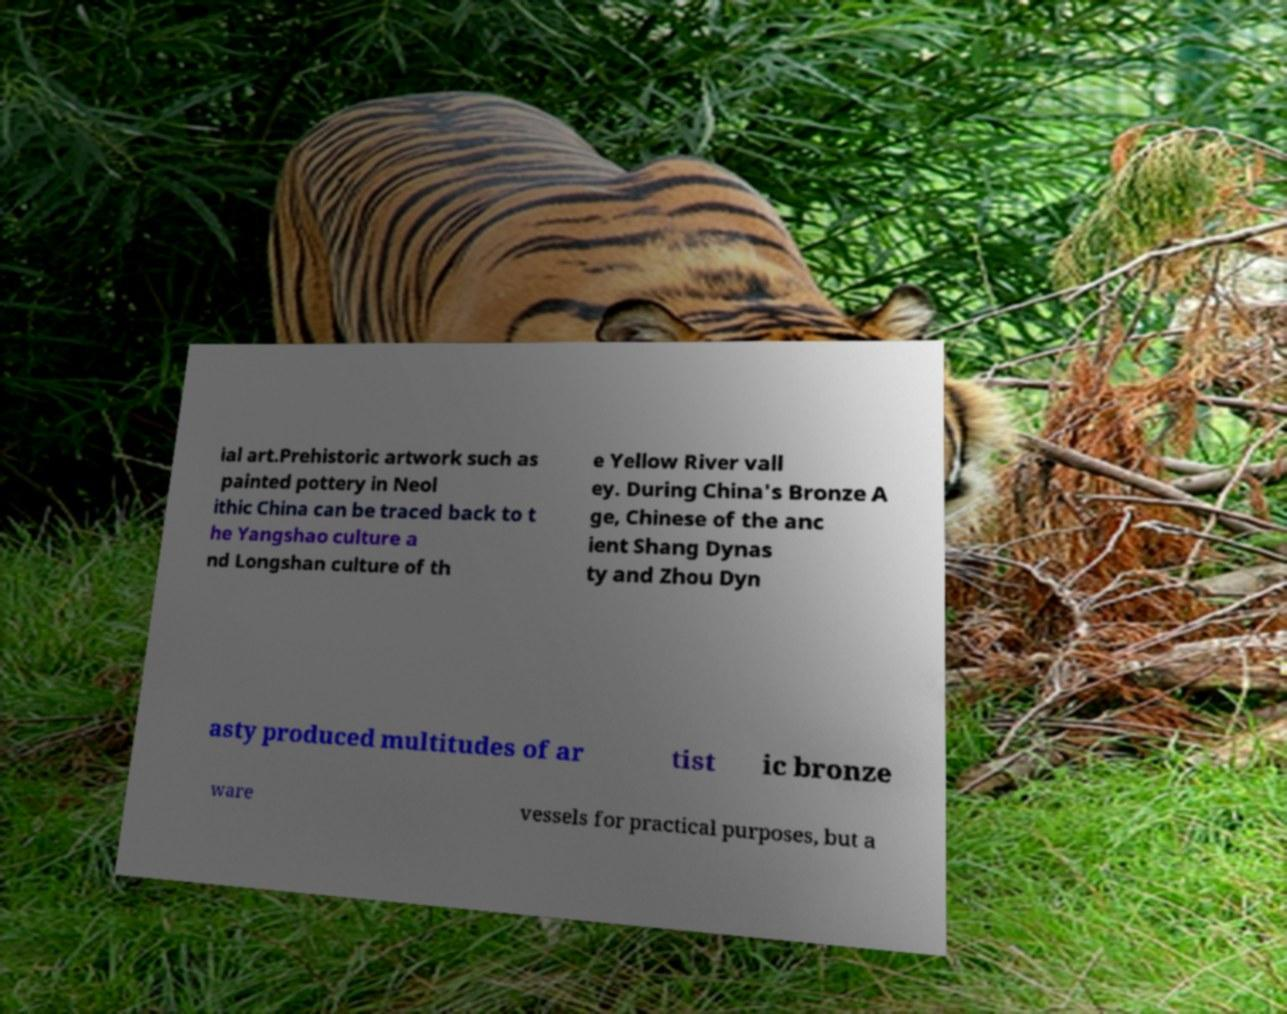What messages or text are displayed in this image? I need them in a readable, typed format. ial art.Prehistoric artwork such as painted pottery in Neol ithic China can be traced back to t he Yangshao culture a nd Longshan culture of th e Yellow River vall ey. During China's Bronze A ge, Chinese of the anc ient Shang Dynas ty and Zhou Dyn asty produced multitudes of ar tist ic bronze ware vessels for practical purposes, but a 